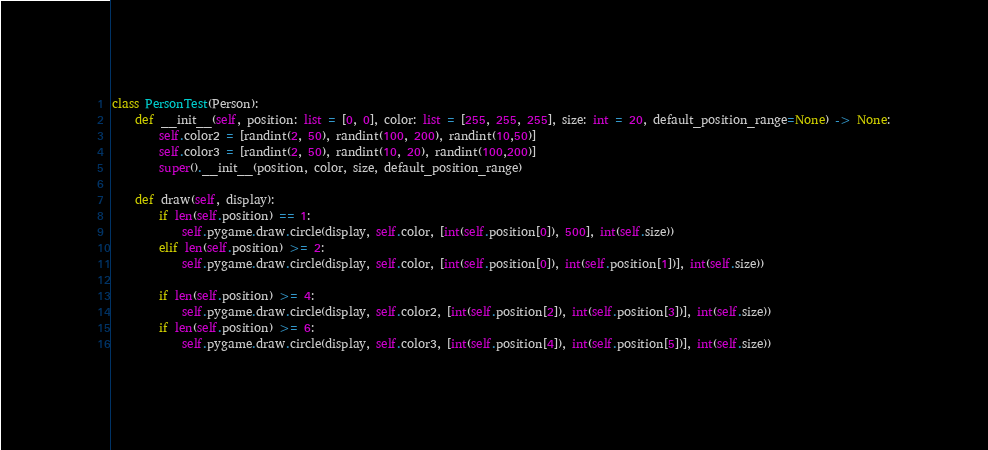<code> <loc_0><loc_0><loc_500><loc_500><_Python_>

class PersonTest(Person):
    def __init__(self, position: list = [0, 0], color: list = [255, 255, 255], size: int = 20, default_position_range=None) -> None:
        self.color2 = [randint(2, 50), randint(100, 200), randint(10,50)]
        self.color3 = [randint(2, 50), randint(10, 20), randint(100,200)]
        super().__init__(position, color, size, default_position_range)

    def draw(self, display):
        if len(self.position) == 1:
            self.pygame.draw.circle(display, self.color, [int(self.position[0]), 500], int(self.size))
        elif len(self.position) >= 2:
            self.pygame.draw.circle(display, self.color, [int(self.position[0]), int(self.position[1])], int(self.size))

        if len(self.position) >= 4:
            self.pygame.draw.circle(display, self.color2, [int(self.position[2]), int(self.position[3])], int(self.size))
        if len(self.position) >= 6:
            self.pygame.draw.circle(display, self.color3, [int(self.position[4]), int(self.position[5])], int(self.size))
</code> 